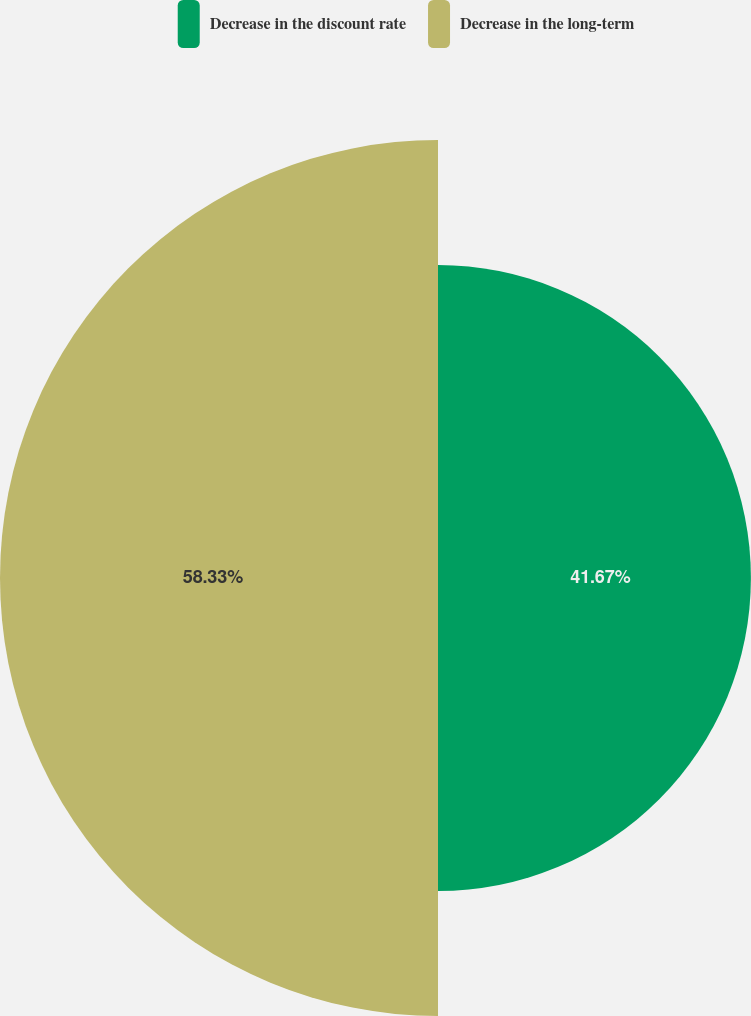<chart> <loc_0><loc_0><loc_500><loc_500><pie_chart><fcel>Decrease in the discount rate<fcel>Decrease in the long-term<nl><fcel>41.67%<fcel>58.33%<nl></chart> 